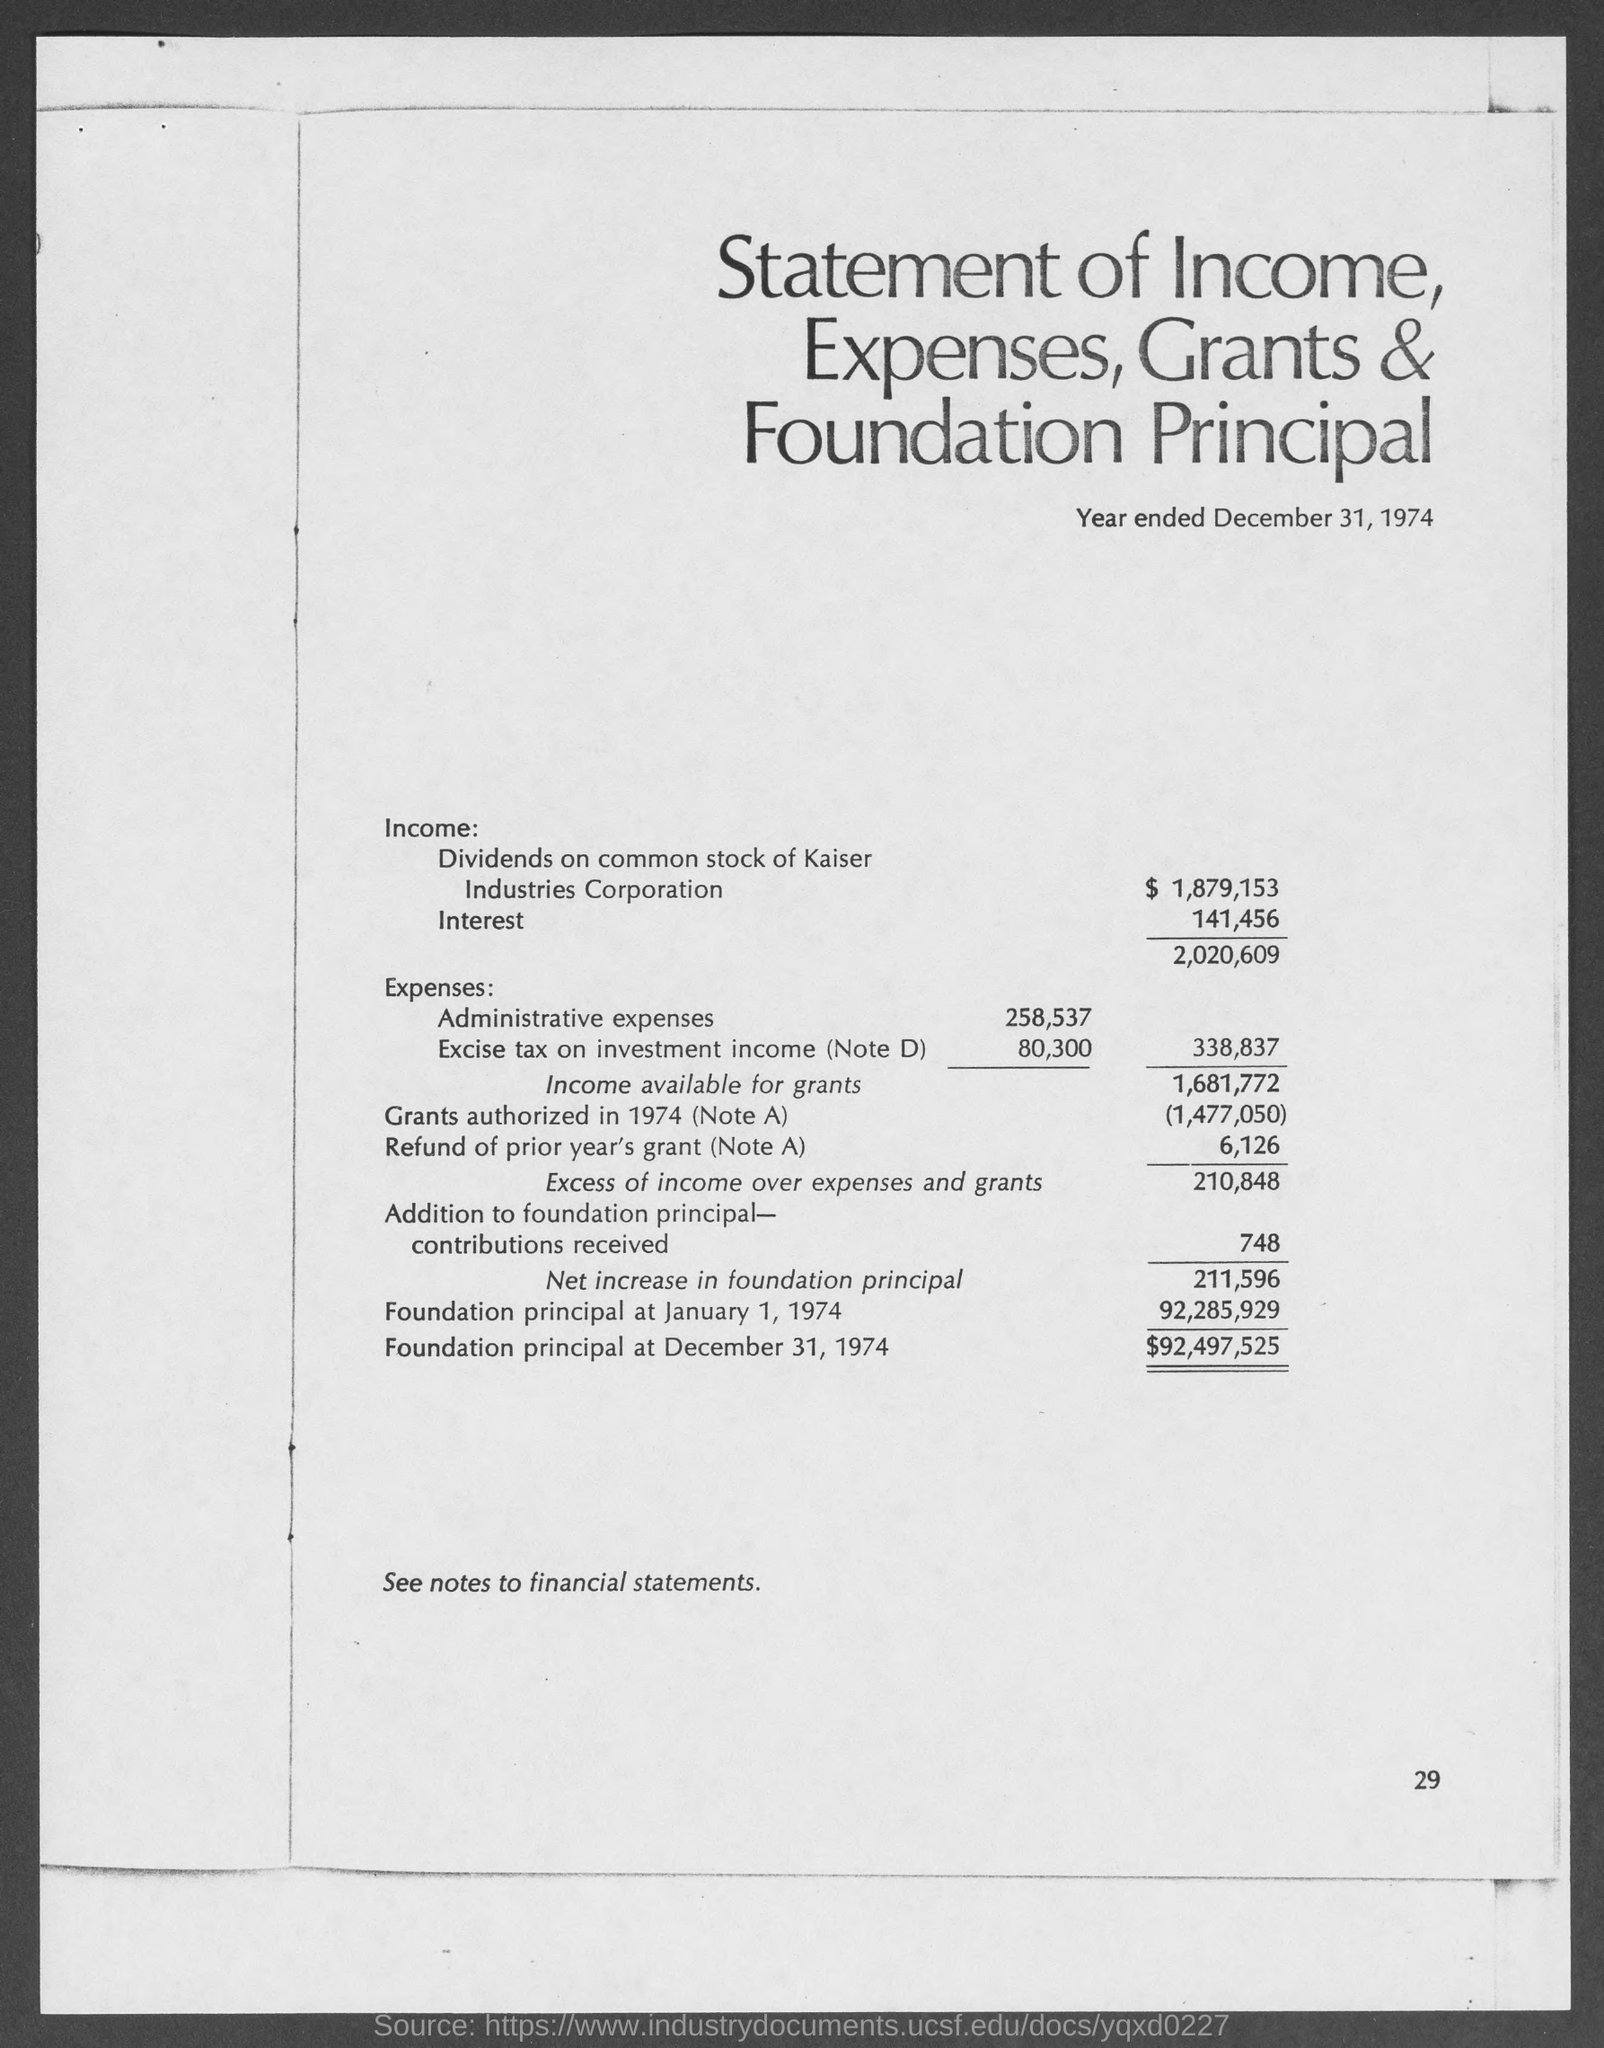What is the heading of the document?
Provide a short and direct response. Statement of Income, Expenses, Grants & Foundation Principal. What is the amount of Interest?
Give a very brief answer. 141,456. What is the amount of Foundation principal at January 1, 1974?
Provide a succinct answer. 92,285,929. 